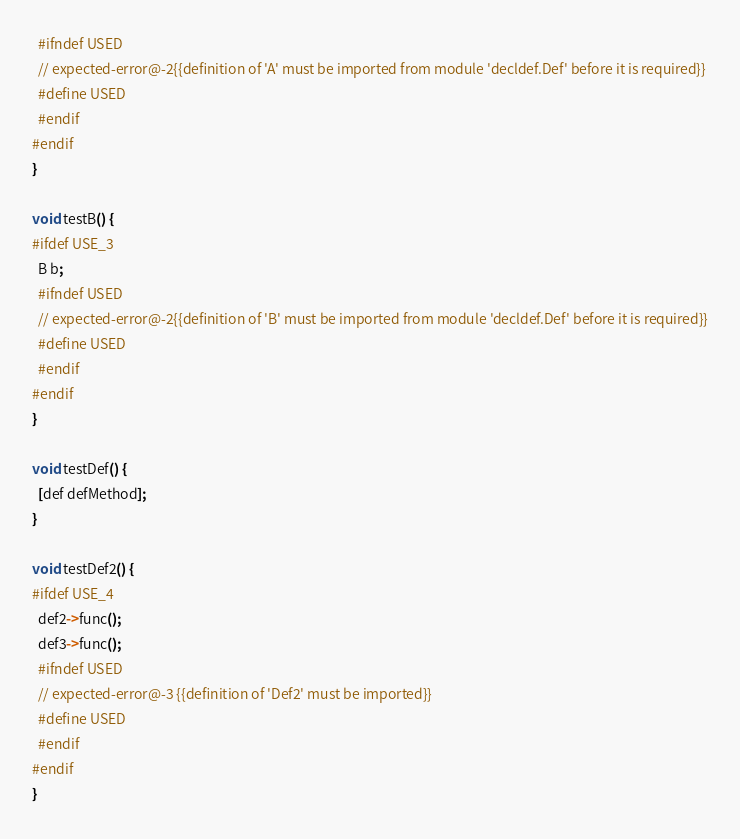<code> <loc_0><loc_0><loc_500><loc_500><_ObjectiveC_>  #ifndef USED
  // expected-error@-2{{definition of 'A' must be imported from module 'decldef.Def' before it is required}}
  #define USED
  #endif
#endif
}

void testB() {
#ifdef USE_3
  B b;
  #ifndef USED
  // expected-error@-2{{definition of 'B' must be imported from module 'decldef.Def' before it is required}}
  #define USED
  #endif
#endif
}

void testDef() {
  [def defMethod];
}

void testDef2() {
#ifdef USE_4
  def2->func();
  def3->func();
  #ifndef USED
  // expected-error@-3 {{definition of 'Def2' must be imported}}
  #define USED
  #endif
#endif
}
</code> 